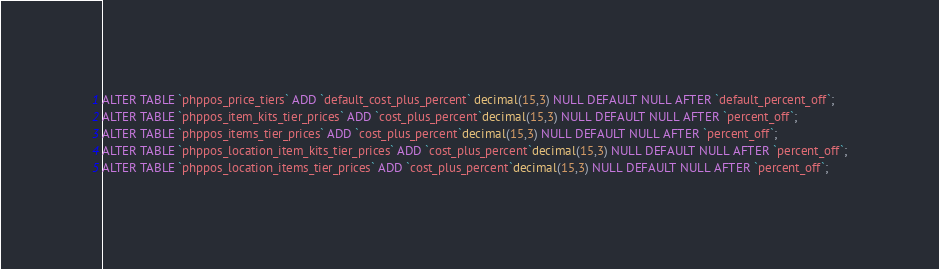Convert code to text. <code><loc_0><loc_0><loc_500><loc_500><_SQL_>ALTER TABLE `phppos_price_tiers` ADD `default_cost_plus_percent` decimal(15,3) NULL DEFAULT NULL AFTER `default_percent_off`;
ALTER TABLE `phppos_item_kits_tier_prices` ADD `cost_plus_percent`decimal(15,3) NULL DEFAULT NULL AFTER `percent_off`;
ALTER TABLE `phppos_items_tier_prices` ADD `cost_plus_percent`decimal(15,3) NULL DEFAULT NULL AFTER `percent_off`;
ALTER TABLE `phppos_location_item_kits_tier_prices` ADD `cost_plus_percent`decimal(15,3) NULL DEFAULT NULL AFTER `percent_off`;
ALTER TABLE `phppos_location_items_tier_prices` ADD `cost_plus_percent`decimal(15,3) NULL DEFAULT NULL AFTER `percent_off`;</code> 